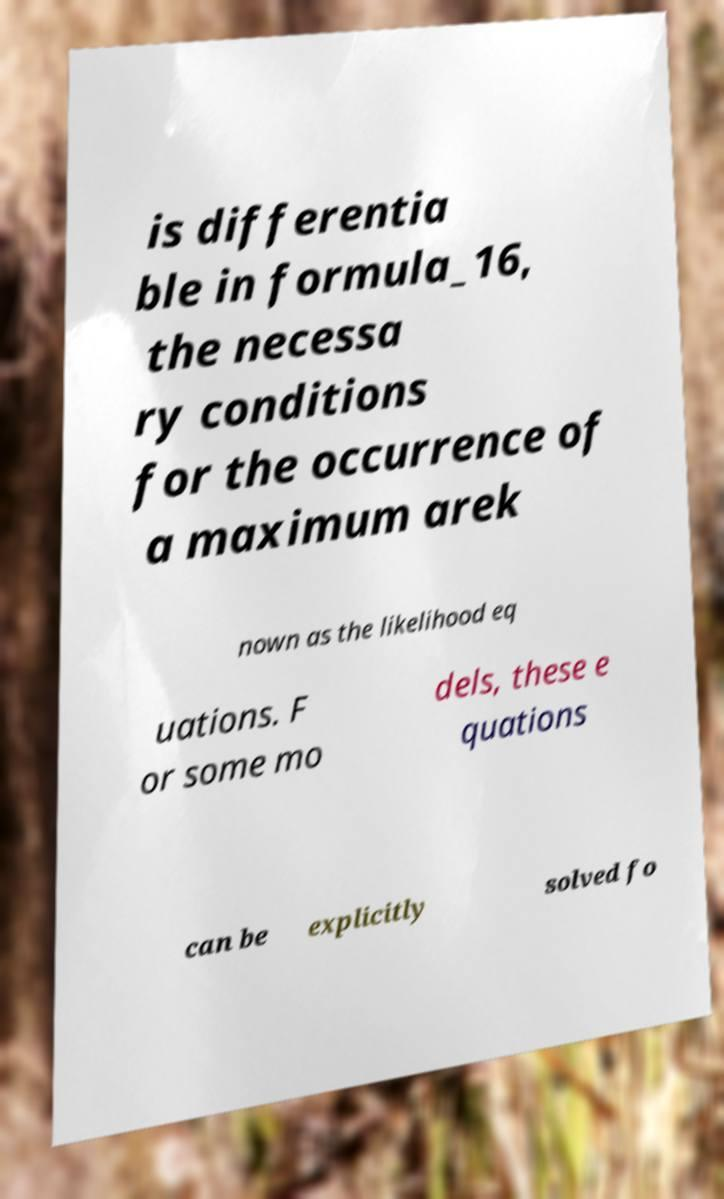Please read and relay the text visible in this image. What does it say? is differentia ble in formula_16, the necessa ry conditions for the occurrence of a maximum arek nown as the likelihood eq uations. F or some mo dels, these e quations can be explicitly solved fo 